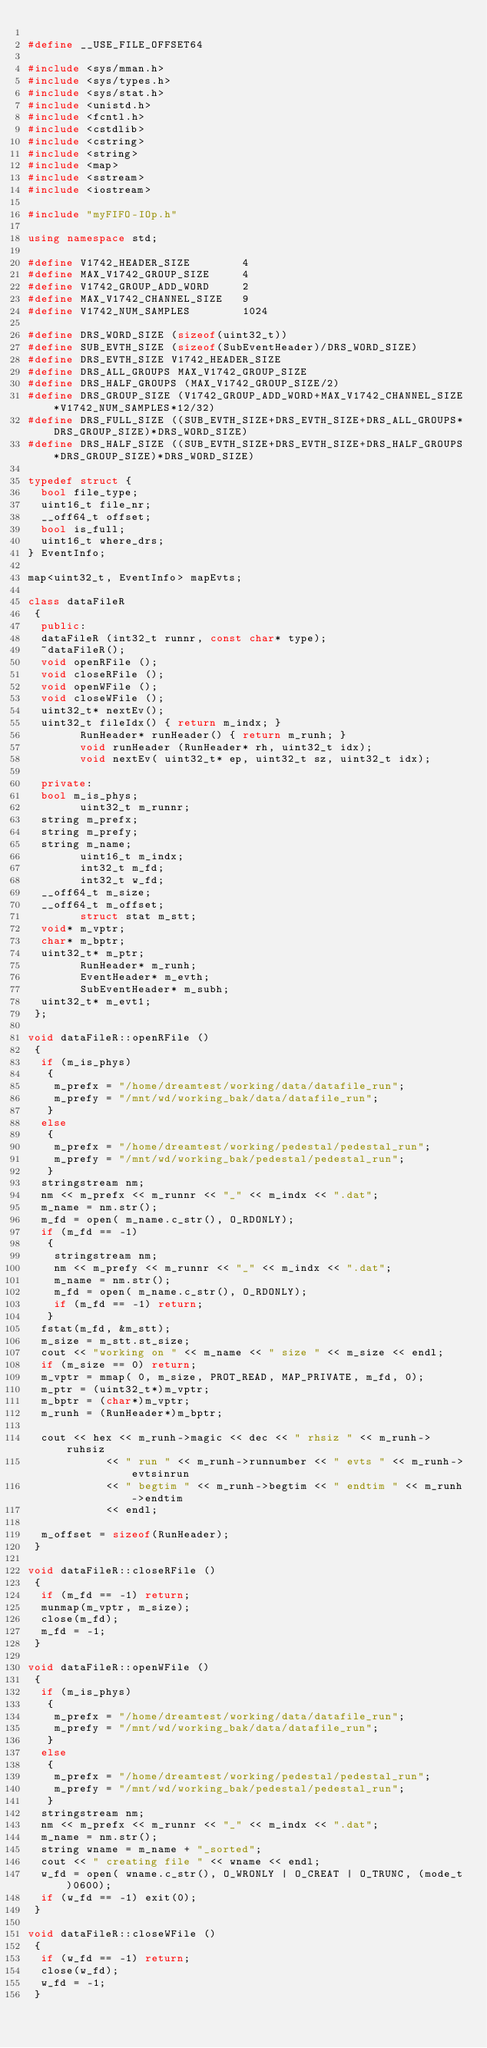<code> <loc_0><loc_0><loc_500><loc_500><_C++_>
#define __USE_FILE_OFFSET64

#include <sys/mman.h>
#include <sys/types.h>
#include <sys/stat.h>
#include <unistd.h>
#include <fcntl.h>
#include <cstdlib>
#include <cstring>
#include <string>
#include <map>
#include <sstream>
#include <iostream>

#include "myFIFO-IOp.h"

using namespace std;

#define V1742_HEADER_SIZE        4
#define MAX_V1742_GROUP_SIZE     4
#define V1742_GROUP_ADD_WORD     2
#define MAX_V1742_CHANNEL_SIZE   9
#define V1742_NUM_SAMPLES        1024

#define DRS_WORD_SIZE (sizeof(uint32_t))
#define SUB_EVTH_SIZE (sizeof(SubEventHeader)/DRS_WORD_SIZE)
#define DRS_EVTH_SIZE V1742_HEADER_SIZE
#define DRS_ALL_GROUPS MAX_V1742_GROUP_SIZE
#define DRS_HALF_GROUPS (MAX_V1742_GROUP_SIZE/2)
#define DRS_GROUP_SIZE (V1742_GROUP_ADD_WORD+MAX_V1742_CHANNEL_SIZE*V1742_NUM_SAMPLES*12/32)
#define DRS_FULL_SIZE ((SUB_EVTH_SIZE+DRS_EVTH_SIZE+DRS_ALL_GROUPS*DRS_GROUP_SIZE)*DRS_WORD_SIZE)
#define DRS_HALF_SIZE ((SUB_EVTH_SIZE+DRS_EVTH_SIZE+DRS_HALF_GROUPS*DRS_GROUP_SIZE)*DRS_WORD_SIZE)

typedef struct {
	bool file_type;
	uint16_t file_nr;
	__off64_t offset;
	bool is_full;
	uint16_t where_drs;
} EventInfo;

map<uint32_t, EventInfo> mapEvts;

class dataFileR
 {
  public:
	dataFileR (int32_t runnr, const char* type);
	~dataFileR();
	void openRFile ();
	void closeRFile ();
	void openWFile ();
	void closeWFile ();
	uint32_t* nextEv();
	uint32_t fileIdx() { return m_indx; }
        RunHeader* runHeader() { return m_runh; }
        void runHeader (RunHeader* rh, uint32_t idx);
        void nextEv( uint32_t* ep, uint32_t sz, uint32_t idx);
	
  private:
	bool m_is_phys;
        uint32_t m_runnr;
	string m_prefx;
	string m_prefy;
	string m_name;
        uint16_t m_indx;
        int32_t m_fd;
        int32_t w_fd;
	__off64_t m_size;
	__off64_t m_offset;
        struct stat m_stt;
	void* m_vptr;
	char* m_bptr;
	uint32_t* m_ptr;
        RunHeader* m_runh;
        EventHeader* m_evth;
        SubEventHeader* m_subh;
	uint32_t* m_evt1;
 };

void dataFileR::openRFile ()
 {
  if (m_is_phys)
   {
    m_prefx = "/home/dreamtest/working/data/datafile_run";
    m_prefy = "/mnt/wd/working_bak/data/datafile_run";
   }
  else
   {
    m_prefx = "/home/dreamtest/working/pedestal/pedestal_run";
    m_prefy = "/mnt/wd/working_bak/pedestal/pedestal_run";
   }
  stringstream nm;
  nm << m_prefx << m_runnr << "_" << m_indx << ".dat";
  m_name = nm.str();
  m_fd = open( m_name.c_str(), O_RDONLY);
  if (m_fd == -1)
   {
    stringstream nm;
    nm << m_prefy << m_runnr << "_" << m_indx << ".dat";
    m_name = nm.str();
    m_fd = open( m_name.c_str(), O_RDONLY);
    if (m_fd == -1) return;
   }
  fstat(m_fd, &m_stt);
  m_size = m_stt.st_size;
  cout << "working on " << m_name << " size " << m_size << endl;
  if (m_size == 0) return;
  m_vptr = mmap( 0, m_size, PROT_READ, MAP_PRIVATE, m_fd, 0);
  m_ptr = (uint32_t*)m_vptr;
  m_bptr = (char*)m_vptr;
  m_runh = (RunHeader*)m_bptr;

  cout << hex << m_runh->magic << dec << " rhsiz " << m_runh->ruhsiz
            << " run " << m_runh->runnumber << " evts " << m_runh->evtsinrun
            << " begtim " << m_runh->begtim << " endtim " << m_runh->endtim
            << endl;

  m_offset = sizeof(RunHeader);
 }
 
void dataFileR::closeRFile ()
 {
  if (m_fd == -1) return;
  munmap(m_vptr, m_size);
  close(m_fd);
  m_fd = -1;
 }

void dataFileR::openWFile ()
 {
  if (m_is_phys)
   {
    m_prefx = "/home/dreamtest/working/data/datafile_run";
    m_prefy = "/mnt/wd/working_bak/data/datafile_run";
   }
  else
   {
    m_prefx = "/home/dreamtest/working/pedestal/pedestal_run";
    m_prefy = "/mnt/wd/working_bak/pedestal/pedestal_run";
   }
  stringstream nm;
  nm << m_prefx << m_runnr << "_" << m_indx << ".dat";
  m_name = nm.str();
  string wname = m_name + "_sorted";
  cout << " creating file " << wname << endl;
  w_fd = open( wname.c_str(), O_WRONLY | O_CREAT | O_TRUNC, (mode_t)0600);
  if (w_fd == -1) exit(0);
 }
 
void dataFileR::closeWFile ()
 {
  if (w_fd == -1) return;
  close(w_fd);
  w_fd = -1;
 }
</code> 